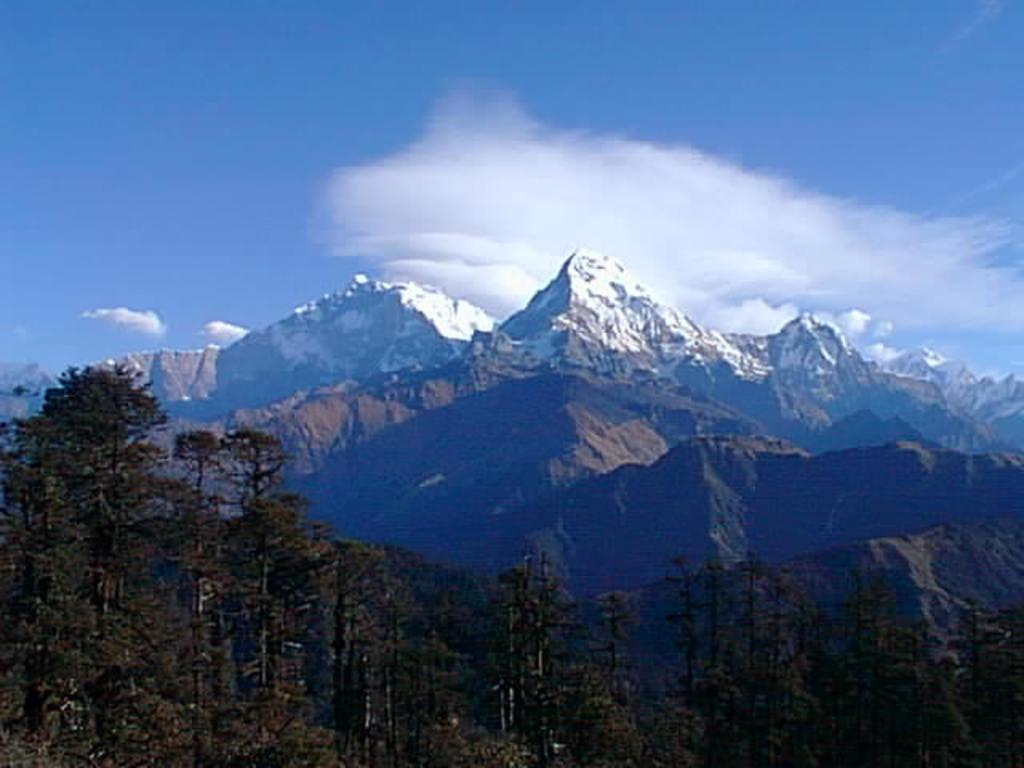What type of geographical feature can be seen in the image? The Himalayan mountains are visible in the image. What is the condition of the mountains in the image? The mountains are covered with snow. What type of vegetation is present in the image? There are trees in the image. What is visible in the sky in the image? Clouds are present in the sky. How many knots are tied on the trees in the image? There are no knots tied on the trees in the image; the trees are simply part of the landscape. What type of jar can be seen on the mountains in the image? There are no jars present on the mountains in the image; the image only shows the Himalayan mountains, snow, trees, and clouds. 